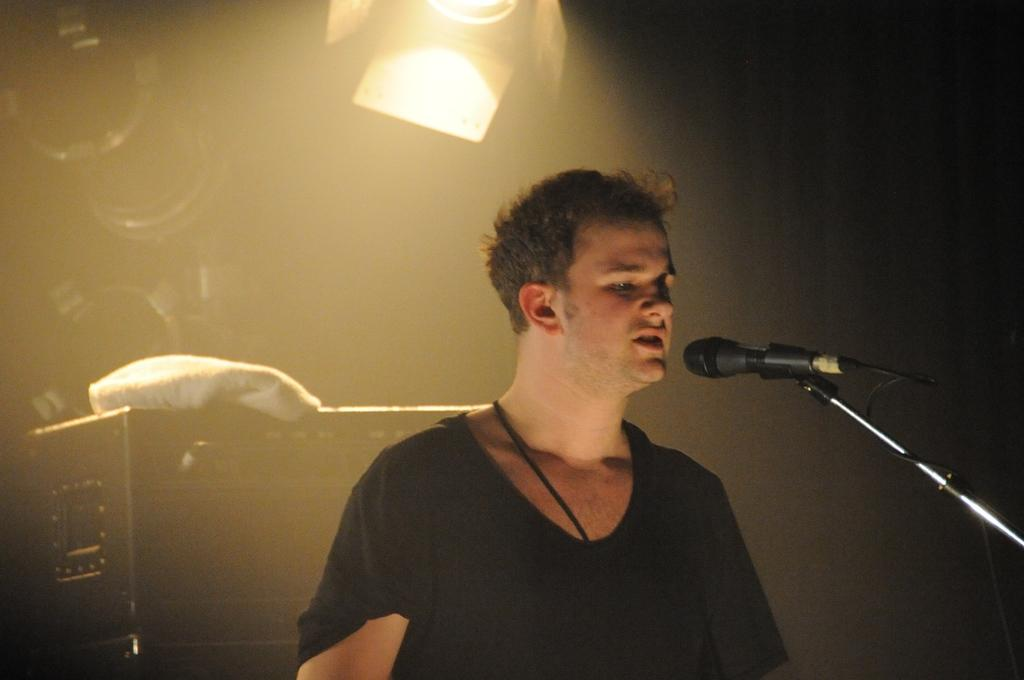What is the main subject of the image? There is a person in the image. What is the person wearing? The person is wearing a black dress. What is the person doing in the image? The person is singing. What is the person using to amplify their voice? There is a microphone in front of the person, and a mic stand is also present. What can be seen in the background of the image? There are objects in the background of the image. What is the source of illumination in the image? There is a light in the image. What is the purpose of the roll in the image? There is no roll present in the image, so it cannot be used for any purpose. 